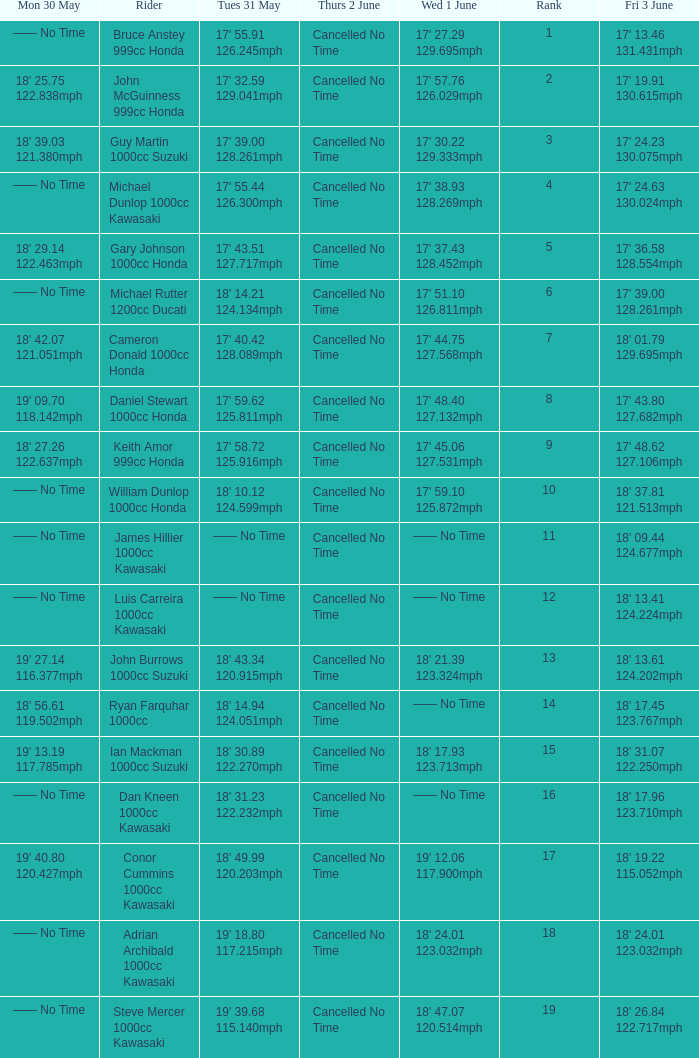What is the Fri 3 June time for the rider whose Tues 31 May time was 19' 18.80 117.215mph? 18' 24.01 123.032mph. 